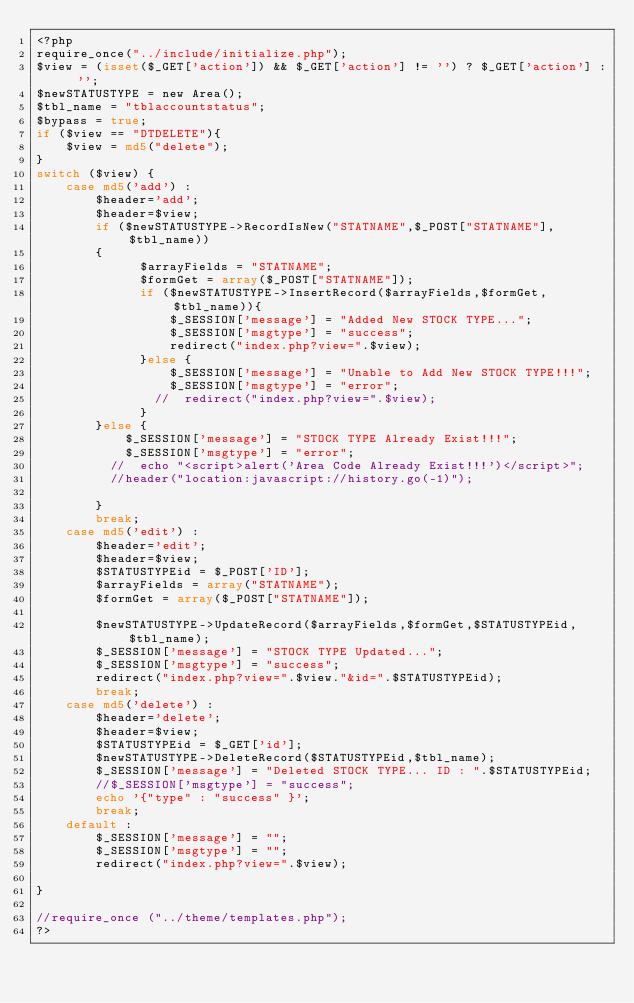<code> <loc_0><loc_0><loc_500><loc_500><_PHP_><?php
require_once("../include/initialize.php");
$view = (isset($_GET['action']) && $_GET['action'] != '') ? $_GET['action'] : '';
$newSTATUSTYPE = new Area();
$tbl_name = "tblaccountstatus";
$bypass = true;
if ($view == "DTDELETE"){
    $view = md5("delete");
}
switch ($view) {
    case md5('add') :
        $header='add';
        $header=$view;
        if ($newSTATUSTYPE->RecordIsNew("STATNAME",$_POST["STATNAME"],$tbl_name))
        {
              $arrayFields = "STATNAME";
              $formGet = array($_POST["STATNAME"]);
              if ($newSTATUSTYPE->InsertRecord($arrayFields,$formGet,$tbl_name)){
                  $_SESSION['message'] = "Added New STOCK TYPE...";
                  $_SESSION['msgtype'] = "success";
                  redirect("index.php?view=".$view);
              }else {
                  $_SESSION['message'] = "Unable to Add New STOCK TYPE!!!";
                  $_SESSION['msgtype'] = "error";
                //  redirect("index.php?view=".$view);
              }
        }else {
            $_SESSION['message'] = "STOCK TYPE Already Exist!!!";
            $_SESSION['msgtype'] = "error";
          //  echo "<script>alert('Area Code Already Exist!!!')</script>";
          //header("location:javascript://history.go(-1)");

        }
        break;
    case md5('edit') :
        $header='edit';
        $header=$view;
        $STATUSTYPEid = $_POST['ID'];
        $arrayFields = array("STATNAME");
        $formGet = array($_POST["STATNAME"]);

        $newSTATUSTYPE->UpdateRecord($arrayFields,$formGet,$STATUSTYPEid,$tbl_name);
        $_SESSION['message'] = "STOCK TYPE Updated...";
        $_SESSION['msgtype'] = "success";
        redirect("index.php?view=".$view."&id=".$STATUSTYPEid);
        break;
    case md5('delete') :
        $header='delete';
        $header=$view;
        $STATUSTYPEid = $_GET['id'];
        $newSTATUSTYPE->DeleteRecord($STATUSTYPEid,$tbl_name);
        $_SESSION['message'] = "Deleted STOCK TYPE... ID : ".$STATUSTYPEid;
        //$_SESSION['msgtype'] = "success";
        echo '{"type" : "success" }';
        break;
    default :
        $_SESSION['message'] = "";
        $_SESSION['msgtype'] = "";
        redirect("index.php?view=".$view);

}

//require_once ("../theme/templates.php");
?>
</code> 